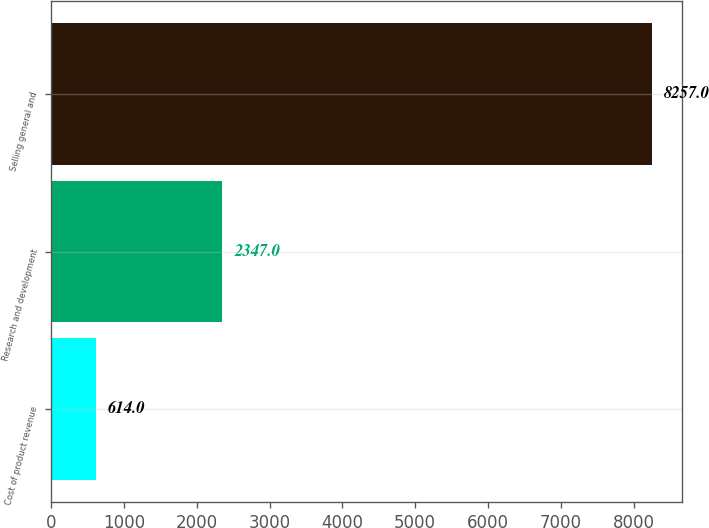Convert chart. <chart><loc_0><loc_0><loc_500><loc_500><bar_chart><fcel>Cost of product revenue<fcel>Research and development<fcel>Selling general and<nl><fcel>614<fcel>2347<fcel>8257<nl></chart> 